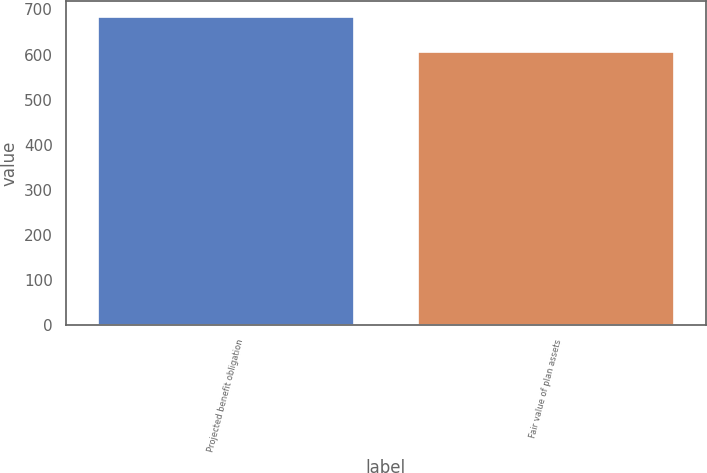Convert chart to OTSL. <chart><loc_0><loc_0><loc_500><loc_500><bar_chart><fcel>Projected benefit obligation<fcel>Fair value of plan assets<nl><fcel>684<fcel>606<nl></chart> 